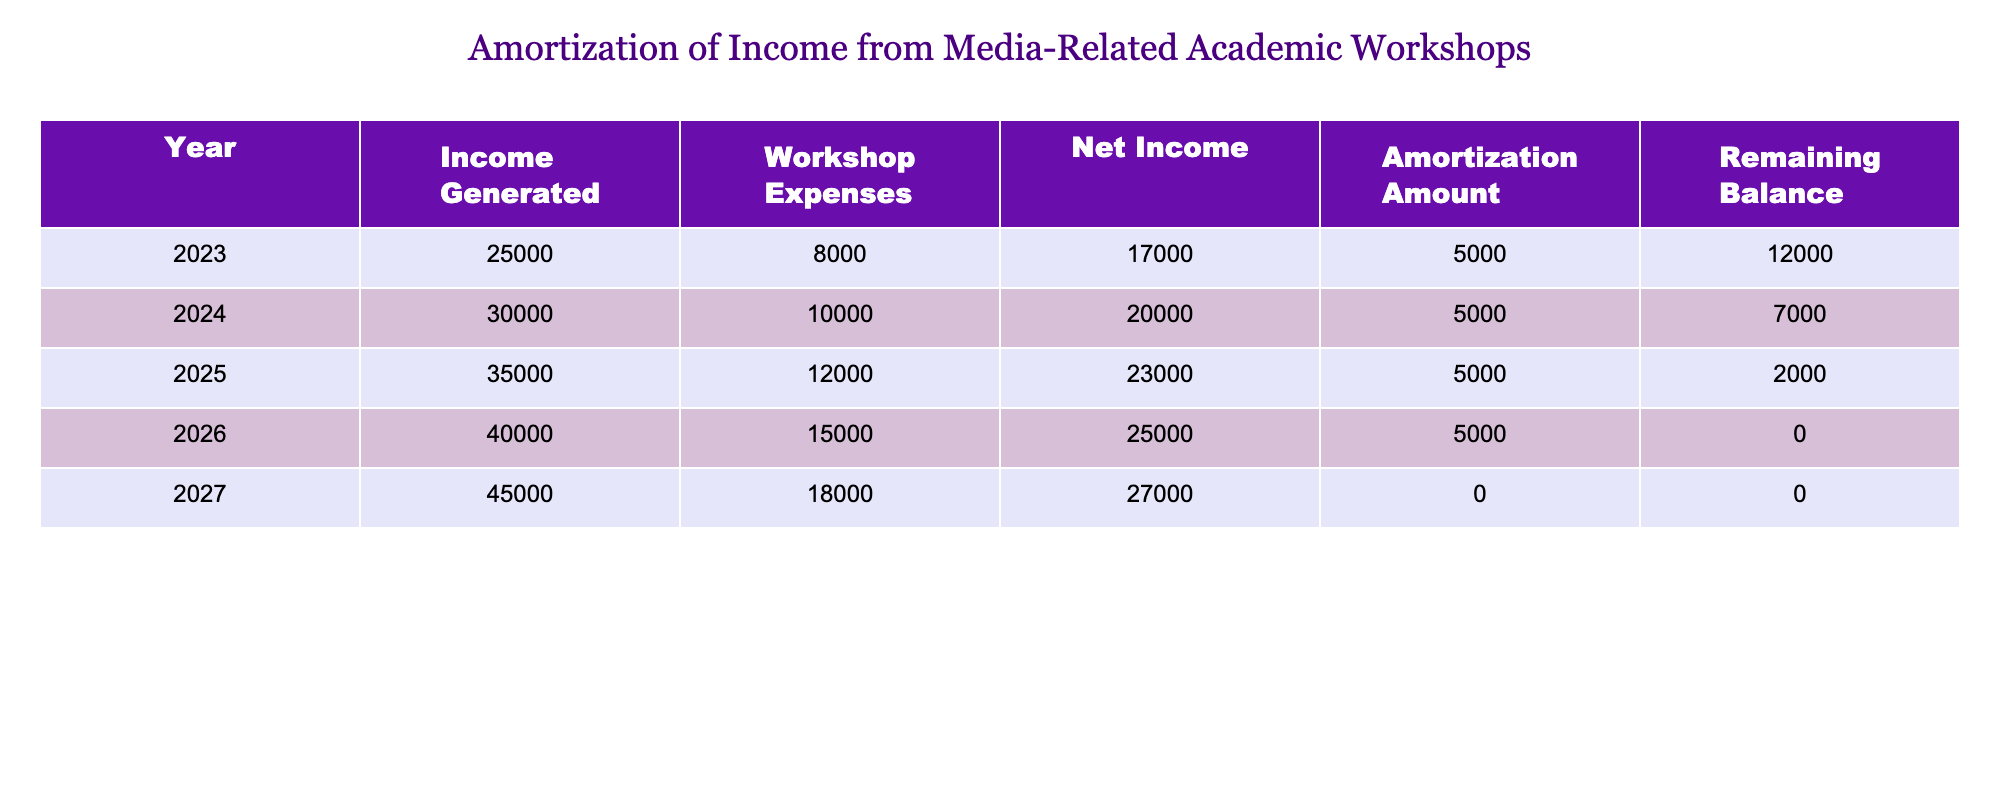What was the net income in 2025? In the table, find the row for the year 2025. The net income for that year is listed directly in the table as 23000.
Answer: 23000 What is the total income generated from workshops over the five years? To find the total income, we add the income generated for each year: 25000 + 30000 + 35000 + 40000 + 45000 = 175000.
Answer: 175000 Was there any amortization amount allocated in 2027? From the table, check the row for the year 2027. It shows an amortization amount of 0, indicating none was allocated for that year.
Answer: No What is the average workshop expenses over the five years? To calculate the average, sum the workshop expenses for each year: 8000 + 10000 + 12000 + 15000 + 18000 = 63000. Then divide by the number of years (5): 63000 / 5 = 12600.
Answer: 12600 What was the remaining balance at the end of 2024? Look at the table for the year 2024. The remaining balance after the amortization amount has been applied is listed as 7000.
Answer: 7000 How much net income was generated in 2023 compared to 2026? The net income for 2023 is 17000, and for 2026, it's 25000. To compare, we assess the difference: 25000 - 17000 = 8000. Therefore, the net income in 2026 was 8000 more than in 2023.
Answer: 8000 more Was the net income in 2024 greater than the workshop expenses for that year? The net income for 2024 is 20000, and the workshop expenses for the same year are 10000. Since 20000 is greater than 10000, the answer is yes.
Answer: Yes What is the total remaining balance at the end of 2026? According to the table, the remaining balance for 2026 is 0. This indicates that all amounts have been fully amortized by the end of that year.
Answer: 0 What was the highest income generated in a single year, and in which year did it occur? The highest income generated is found by checking all the years in the table. The maximum income of 45000 occurred in 2027.
Answer: 45000 in 2027 